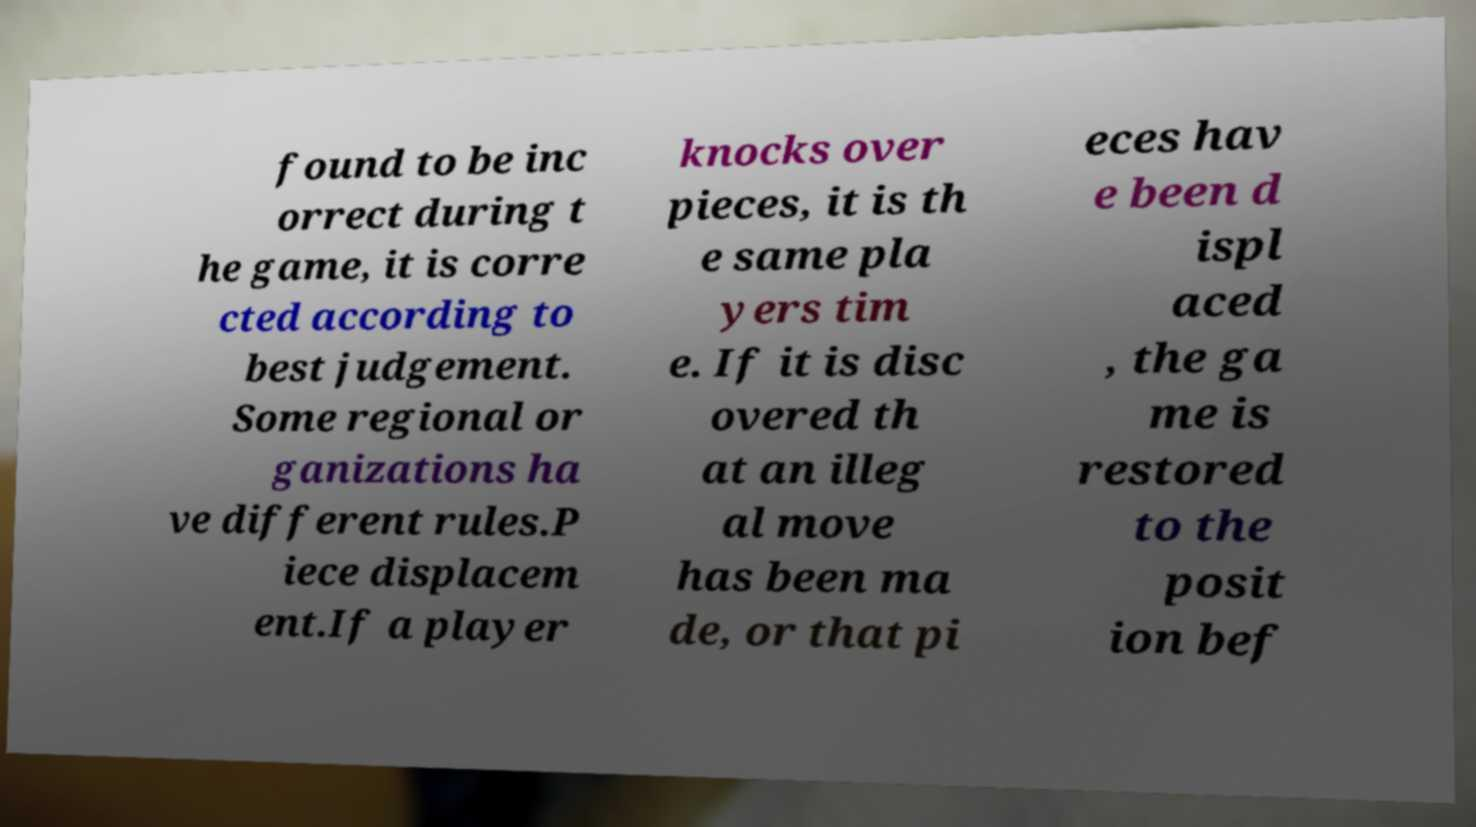Could you extract and type out the text from this image? found to be inc orrect during t he game, it is corre cted according to best judgement. Some regional or ganizations ha ve different rules.P iece displacem ent.If a player knocks over pieces, it is th e same pla yers tim e. If it is disc overed th at an illeg al move has been ma de, or that pi eces hav e been d ispl aced , the ga me is restored to the posit ion bef 